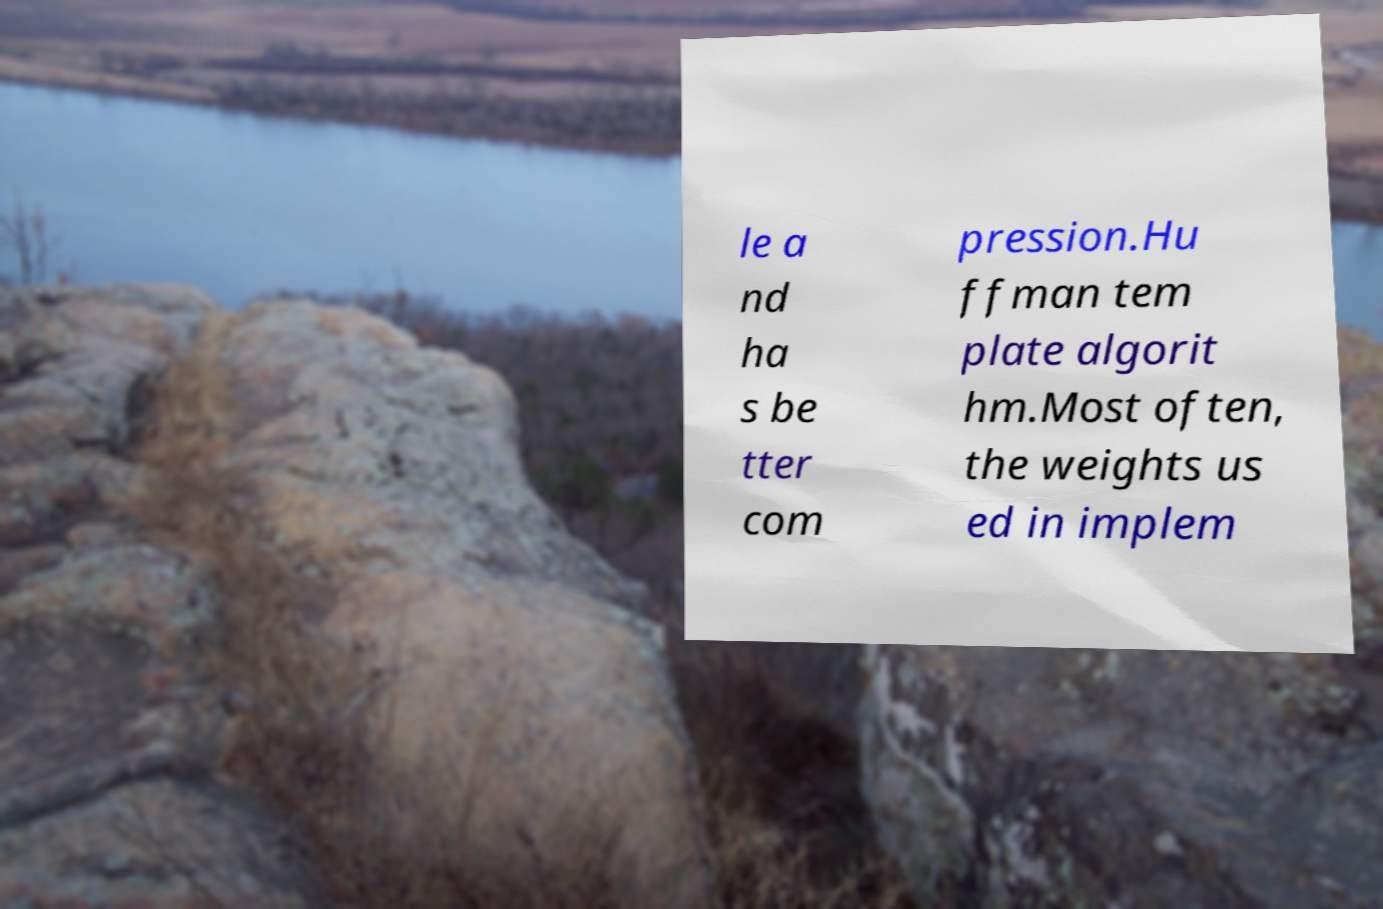For documentation purposes, I need the text within this image transcribed. Could you provide that? le a nd ha s be tter com pression.Hu ffman tem plate algorit hm.Most often, the weights us ed in implem 